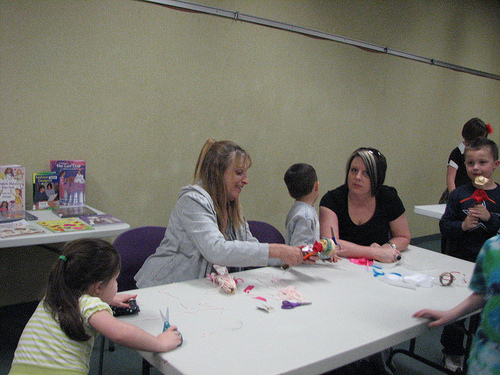<image>
Can you confirm if the woman is to the left of the boy? No. The woman is not to the left of the boy. From this viewpoint, they have a different horizontal relationship. Is there a woman in front of the table? No. The woman is not in front of the table. The spatial positioning shows a different relationship between these objects. Is the kid above the table? No. The kid is not positioned above the table. The vertical arrangement shows a different relationship. 